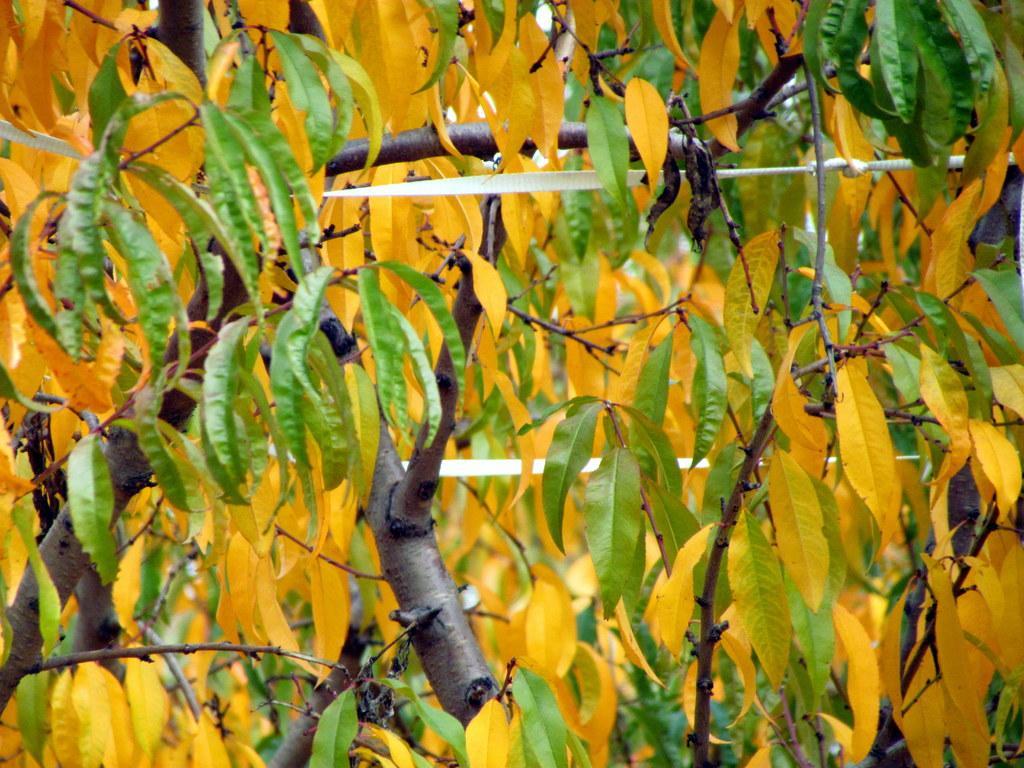How would you summarize this image in a sentence or two? In this picture we can see yellow and green leaves and in the background we can see trees. 